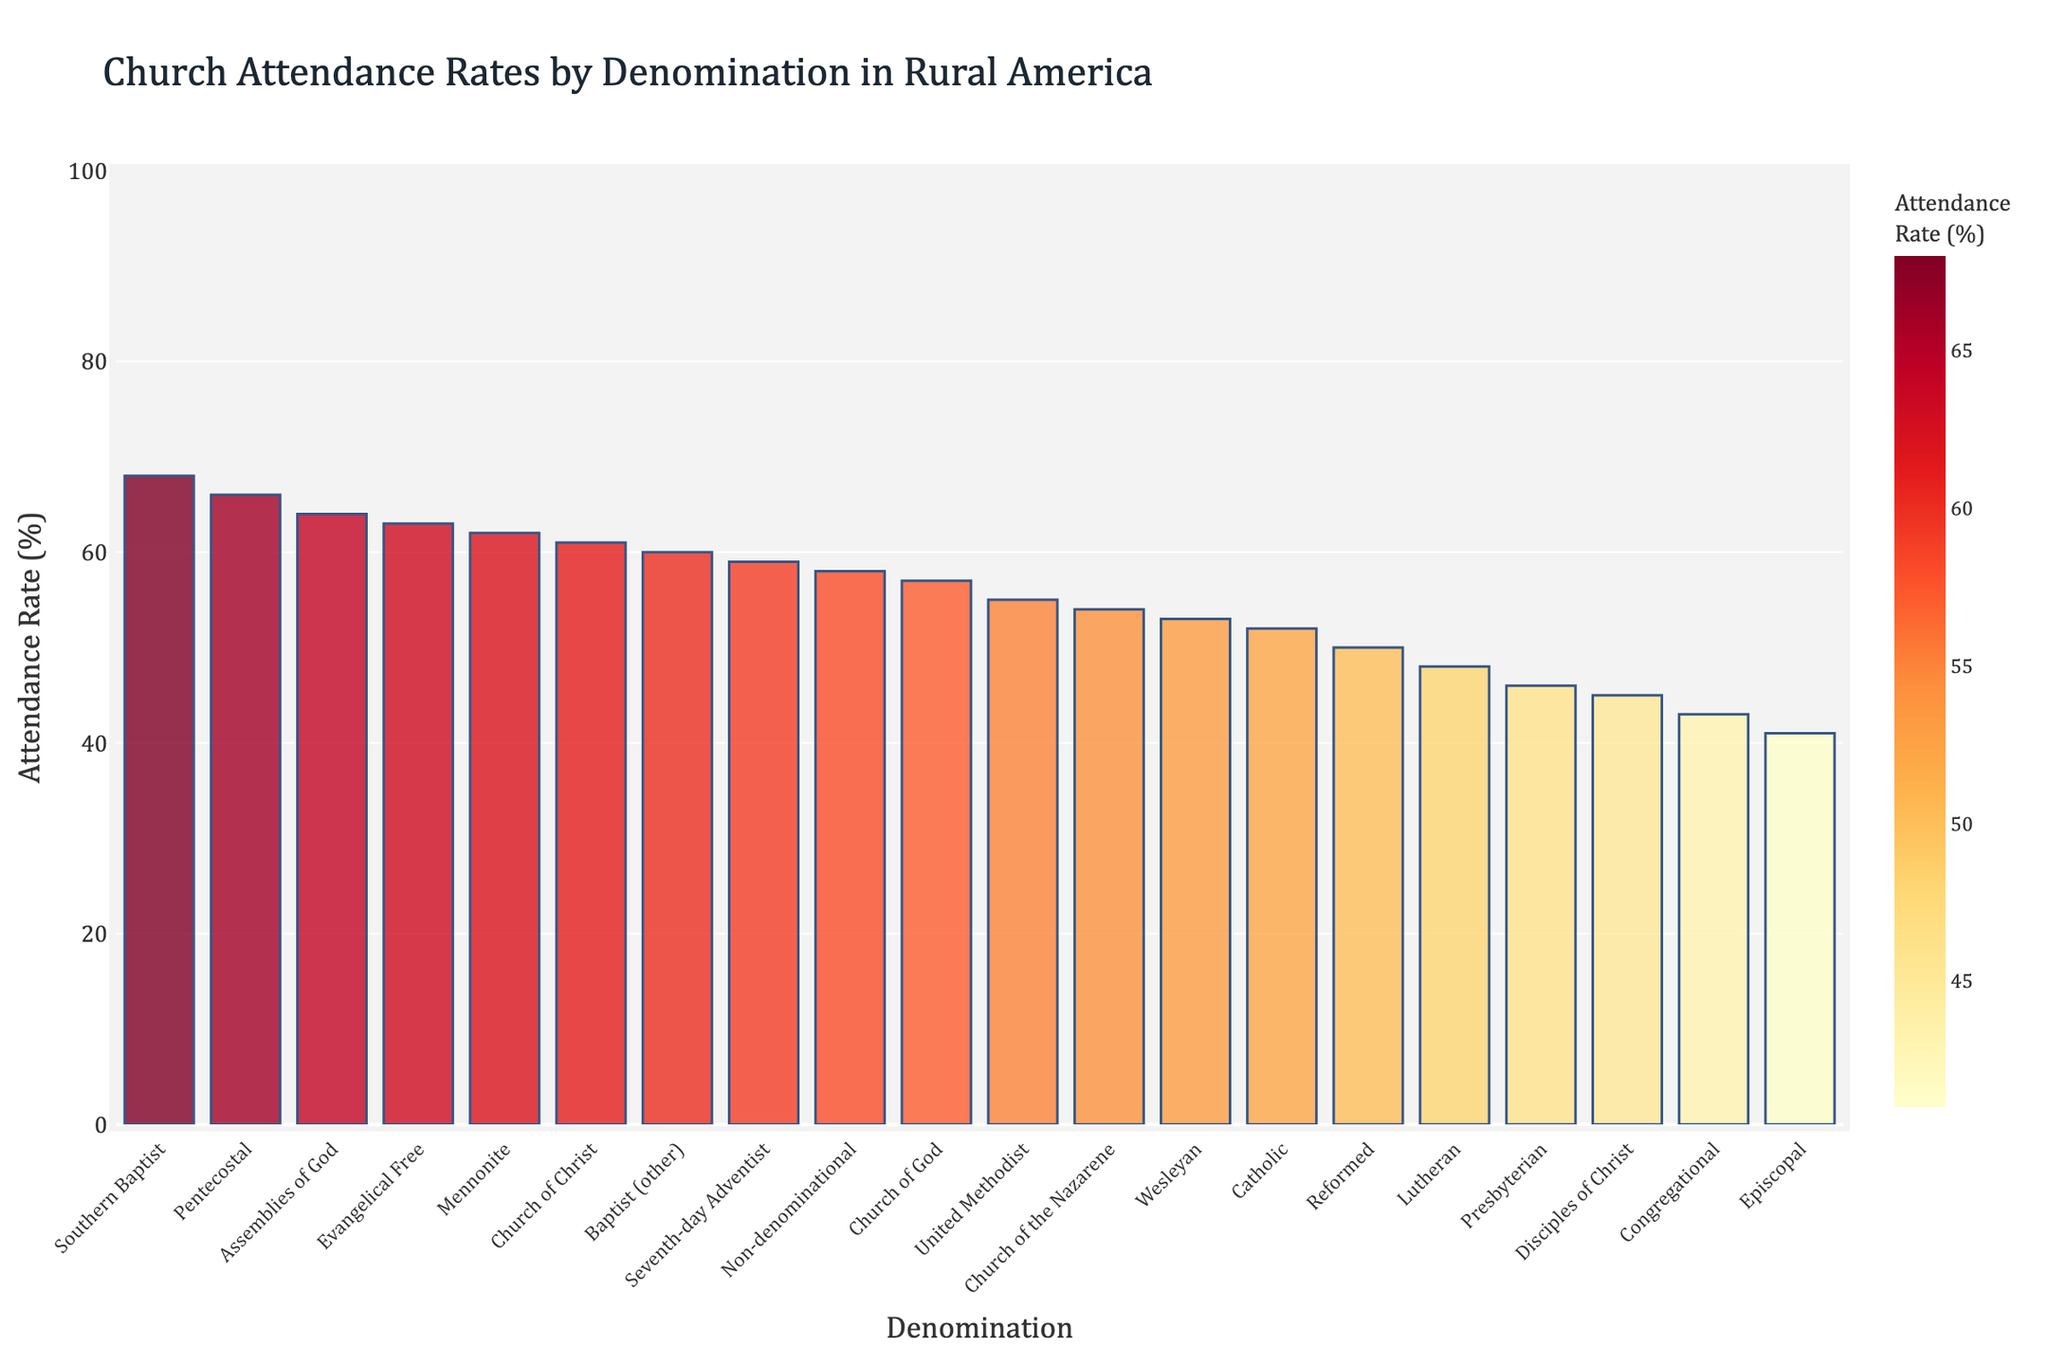Which denomination has the highest attendance rate? The tallest bar in the chart represents the denomination with the highest attendance rate. According to the figure, the "Southern Baptist" bar is the tallest.
Answer: Southern Baptist Which denomination has the lowest attendance rate? The shortest bar in the chart represents the denomination with the lowest attendance rate. The "Episcopal" bar is the shortest.
Answer: Episcopal What is the difference in attendance rate between the Southern Baptist and Episcopal denominations? Subtract the attendance rate of the Episcopal denomination from the attendance rate of the Southern Baptist denomination: 68 - 41.
Answer: 27 Which denominations have an attendance rate greater than 60%? Identify all bars that exceed the 60% mark. The denominations with bars higher than this threshold are: "Southern Baptist," "Church of Christ," "Assemblies of God," "Evangelical Free," "Pentecostal," "Mennonite," and "Baptist (other)."
Answer: Southern Baptist, Church of Christ, Assemblies of God, Evangelical Free, Pentecostal, Mennonite, Baptist (other) What is the average attendance rate of the top five denominations with the highest attendance rates? Identify the top five tallest bars (Southern Baptist, Assemblies of God, Pentecostal, Evangelical Free, and Church of Christ). Calculate the average: (68 + 64 + 66 + 63 + 61) / 5.
Answer: 64.4 Which denominations have attendance rates within 50-60%? Identify all bars that fall within the 50% and 60% range exclusive. The denominations falling within this range are: "Catholic," "Seventh-day Adventist," "Church of God," "Non-denominational," "Church of the Nazarene," "Wesleyan."
Answer: Catholic, Seventh-day Adventist, Church of God, Non-denominational, Church of the Nazarene, Wesleyan Compare the attendance rates of Catholic and Lutheran denominations. Locate the bars for Catholic and Lutheran and observe their heights. Catholic is at 52%, and Lutheran is at 48%.
Answer: Catholic is higher What is the total attendance rate for the Assemblies of God, Church of Christ, and Evangelical Free denominations combined? Sum the attendance rates of these three denominations: 64 + 61 + 63.
Answer: 188 Identify the denominator whose attendance rate is exactly in the middle of the attendance rates of Southern Baptist and Episcopal. Calculate the middle value: (68 + 41) / 2 = 54.5. The closest denominations to this value are "Church of the Nazarene" (54) and "Non-denominational" (58).
Answer: Church of the Nazarene or Non-denominational 